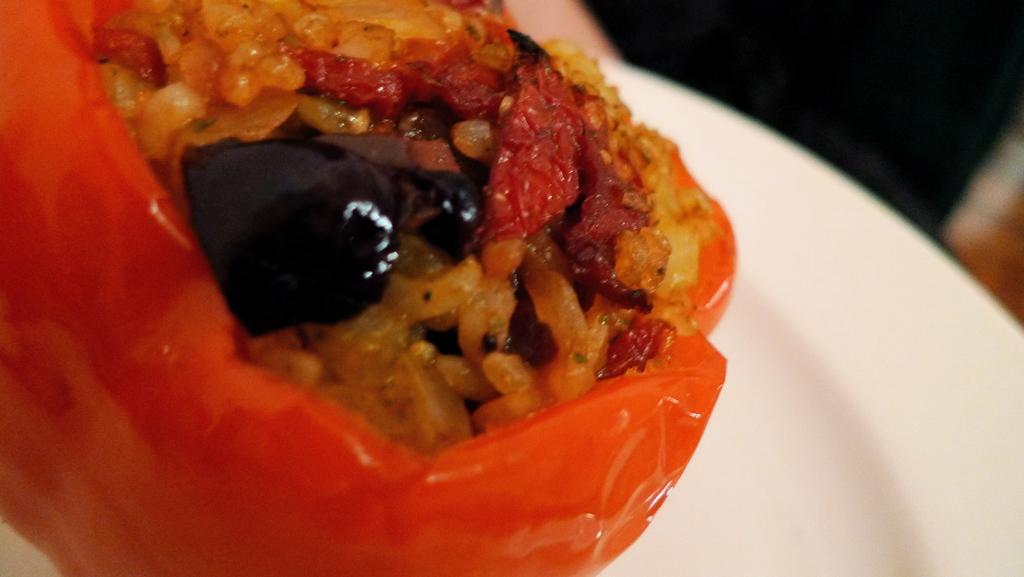Describe this image in one or two sentences. In this image we can see some food on the white plate, one object at the top of the image, one object on the right side of the image and the background is blurred. 